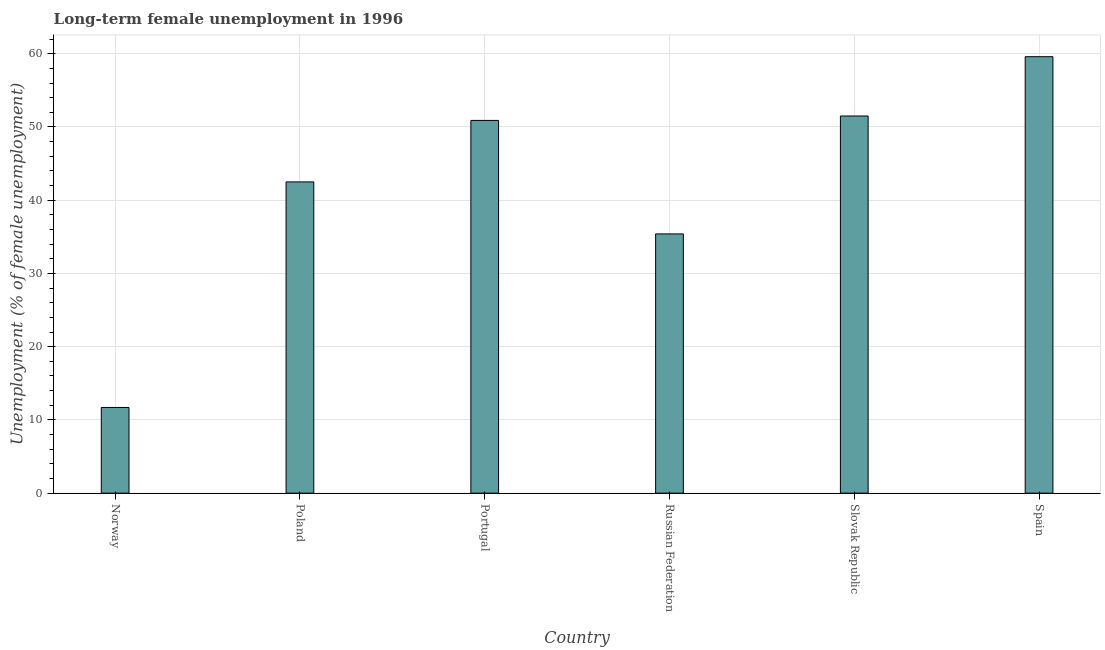What is the title of the graph?
Give a very brief answer. Long-term female unemployment in 1996. What is the label or title of the Y-axis?
Provide a succinct answer. Unemployment (% of female unemployment). What is the long-term female unemployment in Spain?
Provide a short and direct response. 59.6. Across all countries, what is the maximum long-term female unemployment?
Provide a succinct answer. 59.6. Across all countries, what is the minimum long-term female unemployment?
Make the answer very short. 11.7. In which country was the long-term female unemployment maximum?
Provide a succinct answer. Spain. In which country was the long-term female unemployment minimum?
Offer a terse response. Norway. What is the sum of the long-term female unemployment?
Your answer should be very brief. 251.6. What is the difference between the long-term female unemployment in Portugal and Slovak Republic?
Provide a short and direct response. -0.6. What is the average long-term female unemployment per country?
Provide a short and direct response. 41.93. What is the median long-term female unemployment?
Provide a succinct answer. 46.7. In how many countries, is the long-term female unemployment greater than 48 %?
Provide a short and direct response. 3. What is the ratio of the long-term female unemployment in Portugal to that in Russian Federation?
Ensure brevity in your answer.  1.44. What is the difference between the highest and the lowest long-term female unemployment?
Ensure brevity in your answer.  47.9. How many bars are there?
Ensure brevity in your answer.  6. How many countries are there in the graph?
Your response must be concise. 6. What is the difference between two consecutive major ticks on the Y-axis?
Your answer should be compact. 10. What is the Unemployment (% of female unemployment) of Norway?
Make the answer very short. 11.7. What is the Unemployment (% of female unemployment) in Poland?
Your answer should be very brief. 42.5. What is the Unemployment (% of female unemployment) in Portugal?
Keep it short and to the point. 50.9. What is the Unemployment (% of female unemployment) of Russian Federation?
Provide a short and direct response. 35.4. What is the Unemployment (% of female unemployment) of Slovak Republic?
Give a very brief answer. 51.5. What is the Unemployment (% of female unemployment) in Spain?
Your answer should be very brief. 59.6. What is the difference between the Unemployment (% of female unemployment) in Norway and Poland?
Give a very brief answer. -30.8. What is the difference between the Unemployment (% of female unemployment) in Norway and Portugal?
Your response must be concise. -39.2. What is the difference between the Unemployment (% of female unemployment) in Norway and Russian Federation?
Your answer should be compact. -23.7. What is the difference between the Unemployment (% of female unemployment) in Norway and Slovak Republic?
Your answer should be compact. -39.8. What is the difference between the Unemployment (% of female unemployment) in Norway and Spain?
Give a very brief answer. -47.9. What is the difference between the Unemployment (% of female unemployment) in Poland and Slovak Republic?
Offer a terse response. -9. What is the difference between the Unemployment (% of female unemployment) in Poland and Spain?
Provide a succinct answer. -17.1. What is the difference between the Unemployment (% of female unemployment) in Portugal and Spain?
Offer a very short reply. -8.7. What is the difference between the Unemployment (% of female unemployment) in Russian Federation and Slovak Republic?
Your response must be concise. -16.1. What is the difference between the Unemployment (% of female unemployment) in Russian Federation and Spain?
Offer a very short reply. -24.2. What is the ratio of the Unemployment (% of female unemployment) in Norway to that in Poland?
Your response must be concise. 0.28. What is the ratio of the Unemployment (% of female unemployment) in Norway to that in Portugal?
Give a very brief answer. 0.23. What is the ratio of the Unemployment (% of female unemployment) in Norway to that in Russian Federation?
Ensure brevity in your answer.  0.33. What is the ratio of the Unemployment (% of female unemployment) in Norway to that in Slovak Republic?
Your answer should be very brief. 0.23. What is the ratio of the Unemployment (% of female unemployment) in Norway to that in Spain?
Keep it short and to the point. 0.2. What is the ratio of the Unemployment (% of female unemployment) in Poland to that in Portugal?
Offer a terse response. 0.83. What is the ratio of the Unemployment (% of female unemployment) in Poland to that in Russian Federation?
Give a very brief answer. 1.2. What is the ratio of the Unemployment (% of female unemployment) in Poland to that in Slovak Republic?
Offer a terse response. 0.82. What is the ratio of the Unemployment (% of female unemployment) in Poland to that in Spain?
Offer a very short reply. 0.71. What is the ratio of the Unemployment (% of female unemployment) in Portugal to that in Russian Federation?
Provide a succinct answer. 1.44. What is the ratio of the Unemployment (% of female unemployment) in Portugal to that in Slovak Republic?
Your answer should be very brief. 0.99. What is the ratio of the Unemployment (% of female unemployment) in Portugal to that in Spain?
Ensure brevity in your answer.  0.85. What is the ratio of the Unemployment (% of female unemployment) in Russian Federation to that in Slovak Republic?
Provide a succinct answer. 0.69. What is the ratio of the Unemployment (% of female unemployment) in Russian Federation to that in Spain?
Your response must be concise. 0.59. What is the ratio of the Unemployment (% of female unemployment) in Slovak Republic to that in Spain?
Keep it short and to the point. 0.86. 